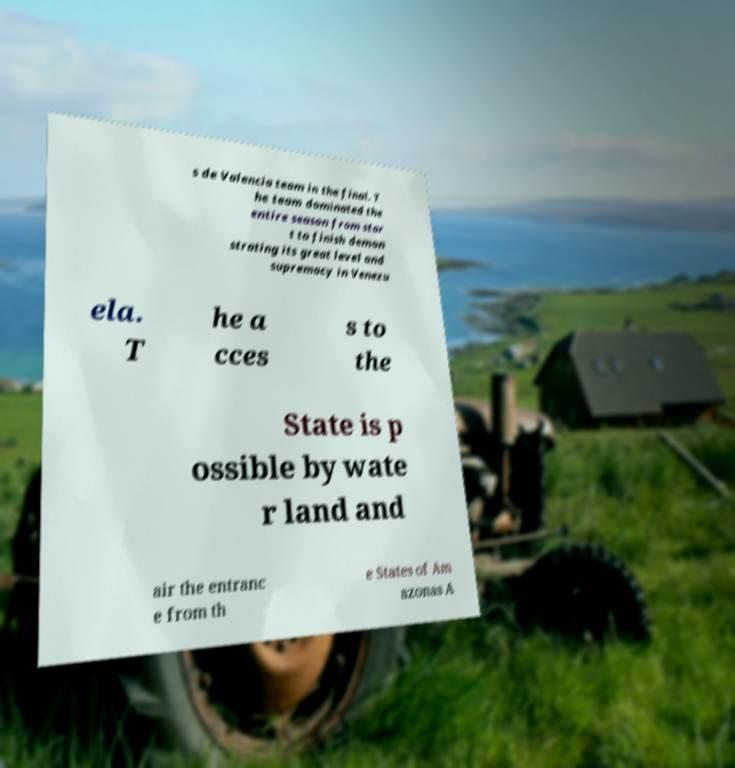Please read and relay the text visible in this image. What does it say? s de Valencia team in the final. T he team dominated the entire season from star t to finish demon strating its great level and supremacy in Venezu ela. T he a cces s to the State is p ossible by wate r land and air the entranc e from th e States of Am azonas A 